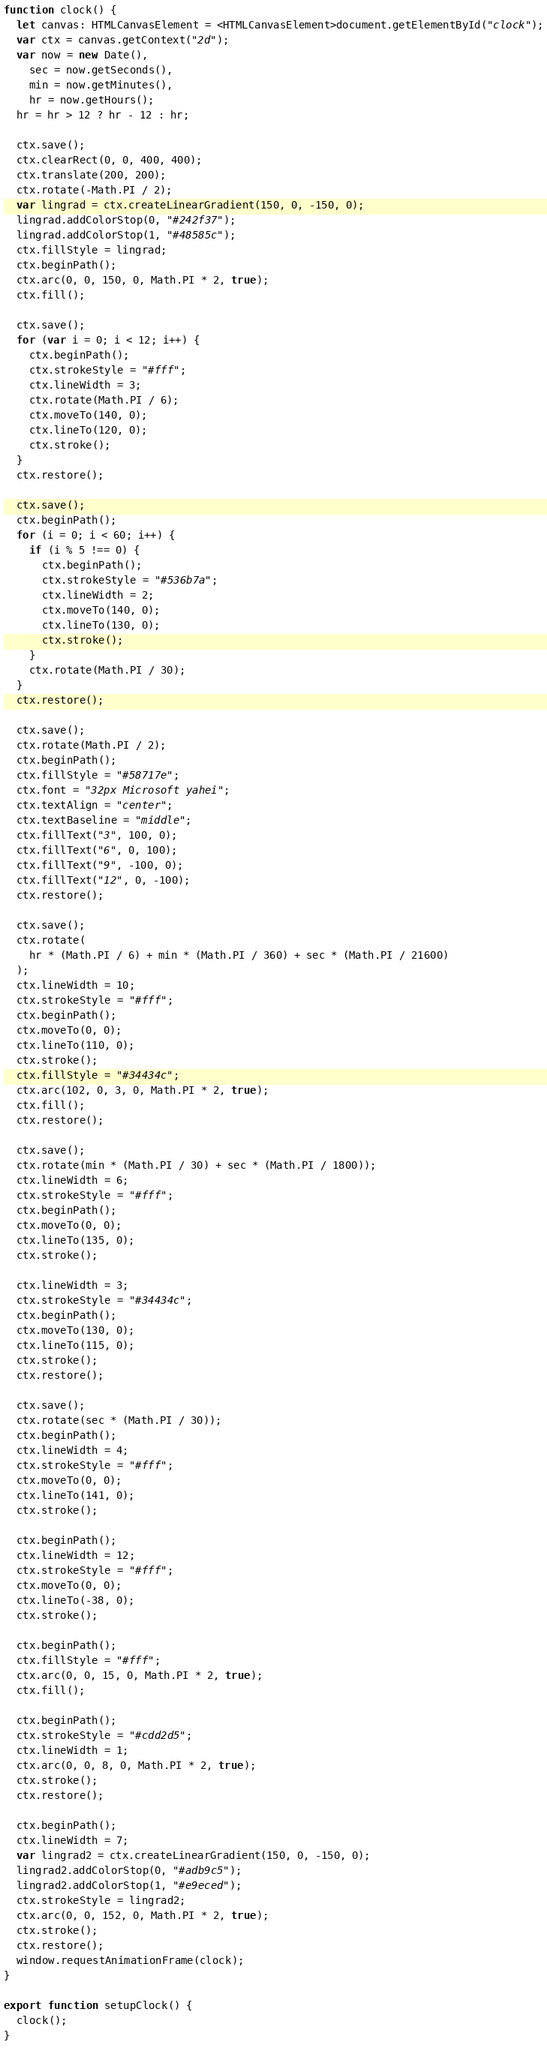<code> <loc_0><loc_0><loc_500><loc_500><_TypeScript_>function clock() {
  let canvas: HTMLCanvasElement = <HTMLCanvasElement>document.getElementById("clock");
  var ctx = canvas.getContext("2d");
  var now = new Date(),
    sec = now.getSeconds(),
    min = now.getMinutes(),
    hr = now.getHours();
  hr = hr > 12 ? hr - 12 : hr;

  ctx.save();
  ctx.clearRect(0, 0, 400, 400);
  ctx.translate(200, 200);
  ctx.rotate(-Math.PI / 2);
  var lingrad = ctx.createLinearGradient(150, 0, -150, 0);
  lingrad.addColorStop(0, "#242f37");
  lingrad.addColorStop(1, "#48585c");
  ctx.fillStyle = lingrad;
  ctx.beginPath();
  ctx.arc(0, 0, 150, 0, Math.PI * 2, true);
  ctx.fill();

  ctx.save();
  for (var i = 0; i < 12; i++) {
    ctx.beginPath();
    ctx.strokeStyle = "#fff";
    ctx.lineWidth = 3;
    ctx.rotate(Math.PI / 6);
    ctx.moveTo(140, 0);
    ctx.lineTo(120, 0);
    ctx.stroke();
  }
  ctx.restore();

  ctx.save();
  ctx.beginPath();
  for (i = 0; i < 60; i++) {
    if (i % 5 !== 0) {
      ctx.beginPath();
      ctx.strokeStyle = "#536b7a";
      ctx.lineWidth = 2;
      ctx.moveTo(140, 0);
      ctx.lineTo(130, 0);
      ctx.stroke();
    }
    ctx.rotate(Math.PI / 30);
  }
  ctx.restore();

  ctx.save();
  ctx.rotate(Math.PI / 2);
  ctx.beginPath();
  ctx.fillStyle = "#58717e";
  ctx.font = "32px Microsoft yahei";
  ctx.textAlign = "center";
  ctx.textBaseline = "middle";
  ctx.fillText("3", 100, 0);
  ctx.fillText("6", 0, 100);
  ctx.fillText("9", -100, 0);
  ctx.fillText("12", 0, -100);
  ctx.restore();

  ctx.save();
  ctx.rotate(
    hr * (Math.PI / 6) + min * (Math.PI / 360) + sec * (Math.PI / 21600)
  );
  ctx.lineWidth = 10;
  ctx.strokeStyle = "#fff";
  ctx.beginPath();
  ctx.moveTo(0, 0);
  ctx.lineTo(110, 0);
  ctx.stroke();
  ctx.fillStyle = "#34434c";
  ctx.arc(102, 0, 3, 0, Math.PI * 2, true);
  ctx.fill();
  ctx.restore();

  ctx.save();
  ctx.rotate(min * (Math.PI / 30) + sec * (Math.PI / 1800));
  ctx.lineWidth = 6;
  ctx.strokeStyle = "#fff";
  ctx.beginPath();
  ctx.moveTo(0, 0);
  ctx.lineTo(135, 0);
  ctx.stroke();

  ctx.lineWidth = 3;
  ctx.strokeStyle = "#34434c";
  ctx.beginPath();
  ctx.moveTo(130, 0);
  ctx.lineTo(115, 0);
  ctx.stroke();
  ctx.restore();

  ctx.save();
  ctx.rotate(sec * (Math.PI / 30));
  ctx.beginPath();
  ctx.lineWidth = 4;
  ctx.strokeStyle = "#fff";
  ctx.moveTo(0, 0);
  ctx.lineTo(141, 0);
  ctx.stroke();

  ctx.beginPath();
  ctx.lineWidth = 12;
  ctx.strokeStyle = "#fff";
  ctx.moveTo(0, 0);
  ctx.lineTo(-38, 0);
  ctx.stroke();

  ctx.beginPath();
  ctx.fillStyle = "#fff";
  ctx.arc(0, 0, 15, 0, Math.PI * 2, true);
  ctx.fill();

  ctx.beginPath();
  ctx.strokeStyle = "#cdd2d5";
  ctx.lineWidth = 1;
  ctx.arc(0, 0, 8, 0, Math.PI * 2, true);
  ctx.stroke();
  ctx.restore();

  ctx.beginPath();
  ctx.lineWidth = 7;
  var lingrad2 = ctx.createLinearGradient(150, 0, -150, 0);
  lingrad2.addColorStop(0, "#adb9c5");
  lingrad2.addColorStop(1, "#e9eced");
  ctx.strokeStyle = lingrad2;
  ctx.arc(0, 0, 152, 0, Math.PI * 2, true);
  ctx.stroke();
  ctx.restore();
  window.requestAnimationFrame(clock);
}

export function setupClock() {
  clock();
}
</code> 